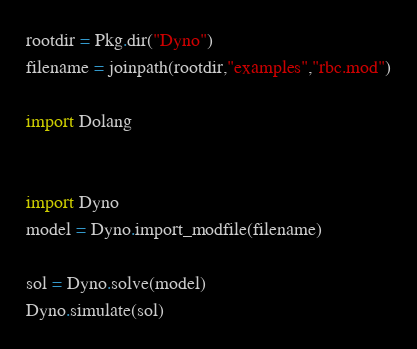<code> <loc_0><loc_0><loc_500><loc_500><_Julia_>
rootdir = Pkg.dir("Dyno")
filename = joinpath(rootdir,"examples","rbc.mod")

import Dolang


import Dyno
model = Dyno.import_modfile(filename)

sol = Dyno.solve(model)
Dyno.simulate(sol)
</code> 